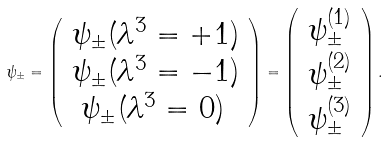Convert formula to latex. <formula><loc_0><loc_0><loc_500><loc_500>\psi _ { \pm } = \left ( \begin{array} { c } \psi _ { \pm } ( \lambda ^ { 3 } = + 1 ) \\ \psi _ { \pm } ( \lambda ^ { 3 } = - 1 ) \\ \psi _ { \pm } ( \lambda ^ { 3 } = 0 ) \, \end{array} \right ) = \left ( \begin{array} { c } \psi _ { \pm } ^ { ( 1 ) } \\ \psi _ { \pm } ^ { ( 2 ) } \\ \psi _ { \pm } ^ { ( 3 ) } \end{array} \right ) .</formula> 